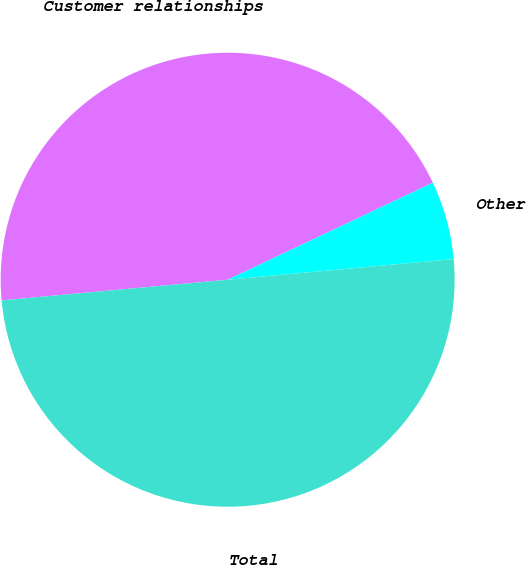Convert chart. <chart><loc_0><loc_0><loc_500><loc_500><pie_chart><fcel>Customer relationships<fcel>Other<fcel>Total<nl><fcel>44.42%<fcel>5.58%<fcel>50.0%<nl></chart> 